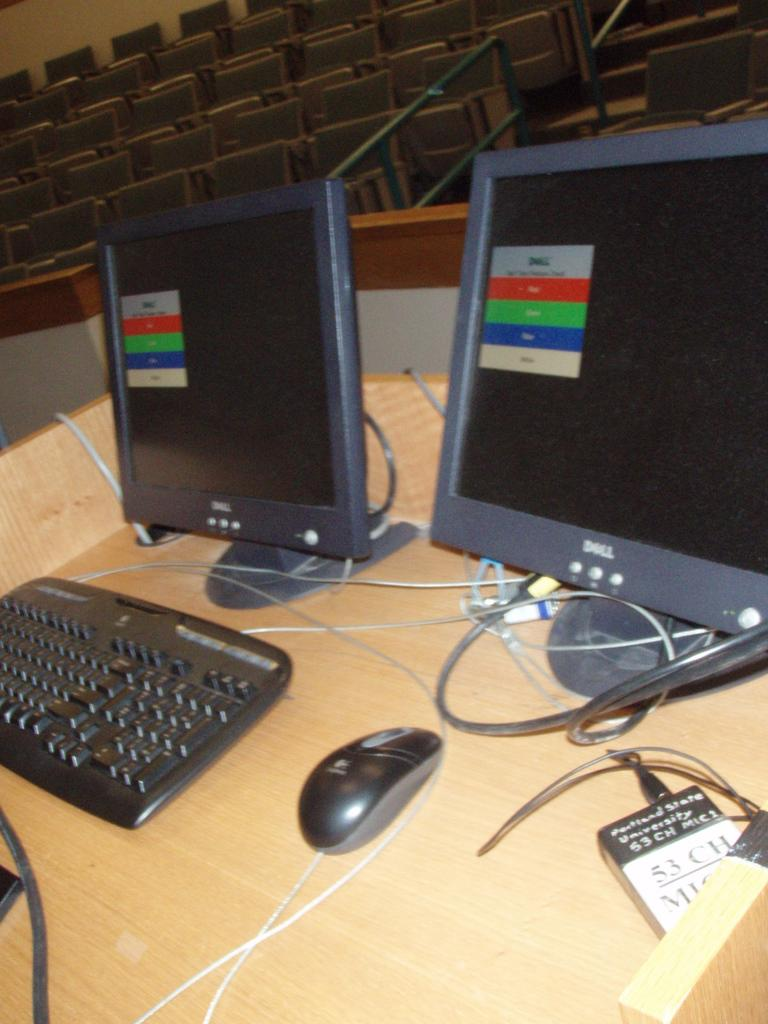What is the main object in the center of the image? There is a desk in the center of the image. What electronic devices are on the desk? There are monitors on the desk. What is used for typing on the desk? There is a keyboard on the desk. What is used for controlling the cursor on the desk? There is a mouse on the desk. Where are the chairs located in the image? The chairs are at the top side of the image. Can you see any kittens fighting with a hen in the image? No, there are no kittens or hens present in the image. 